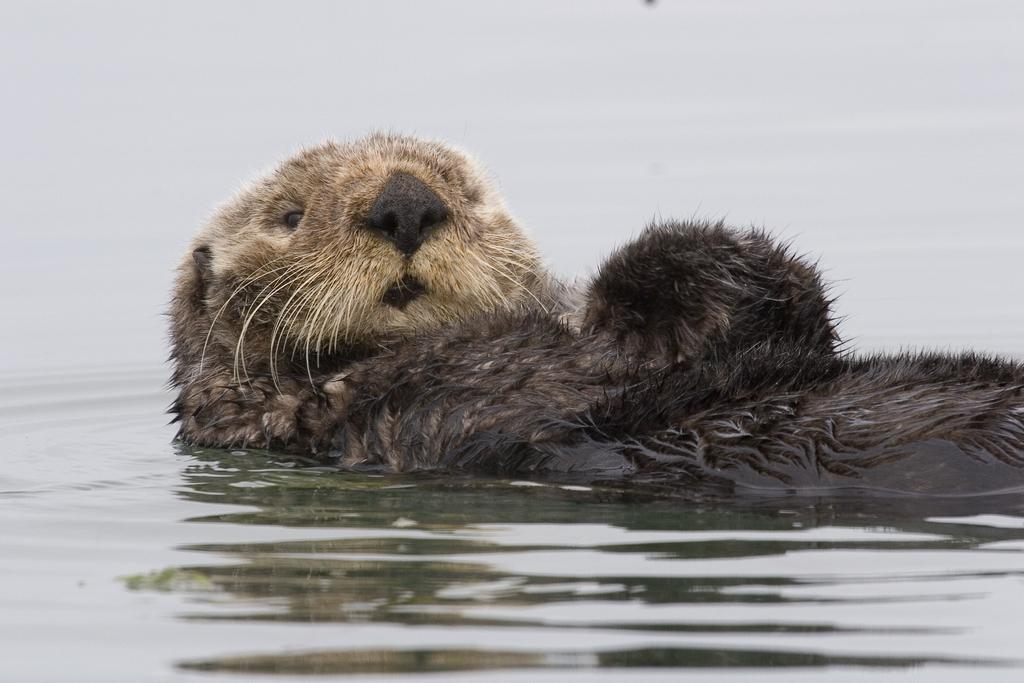What type of animal is in the image? The type of animal cannot be determined from the provided facts. What is the primary element visible in the image? Water is visible in the image. What grade does the ice receive in the image? There is no ice or grading system present in the image. 